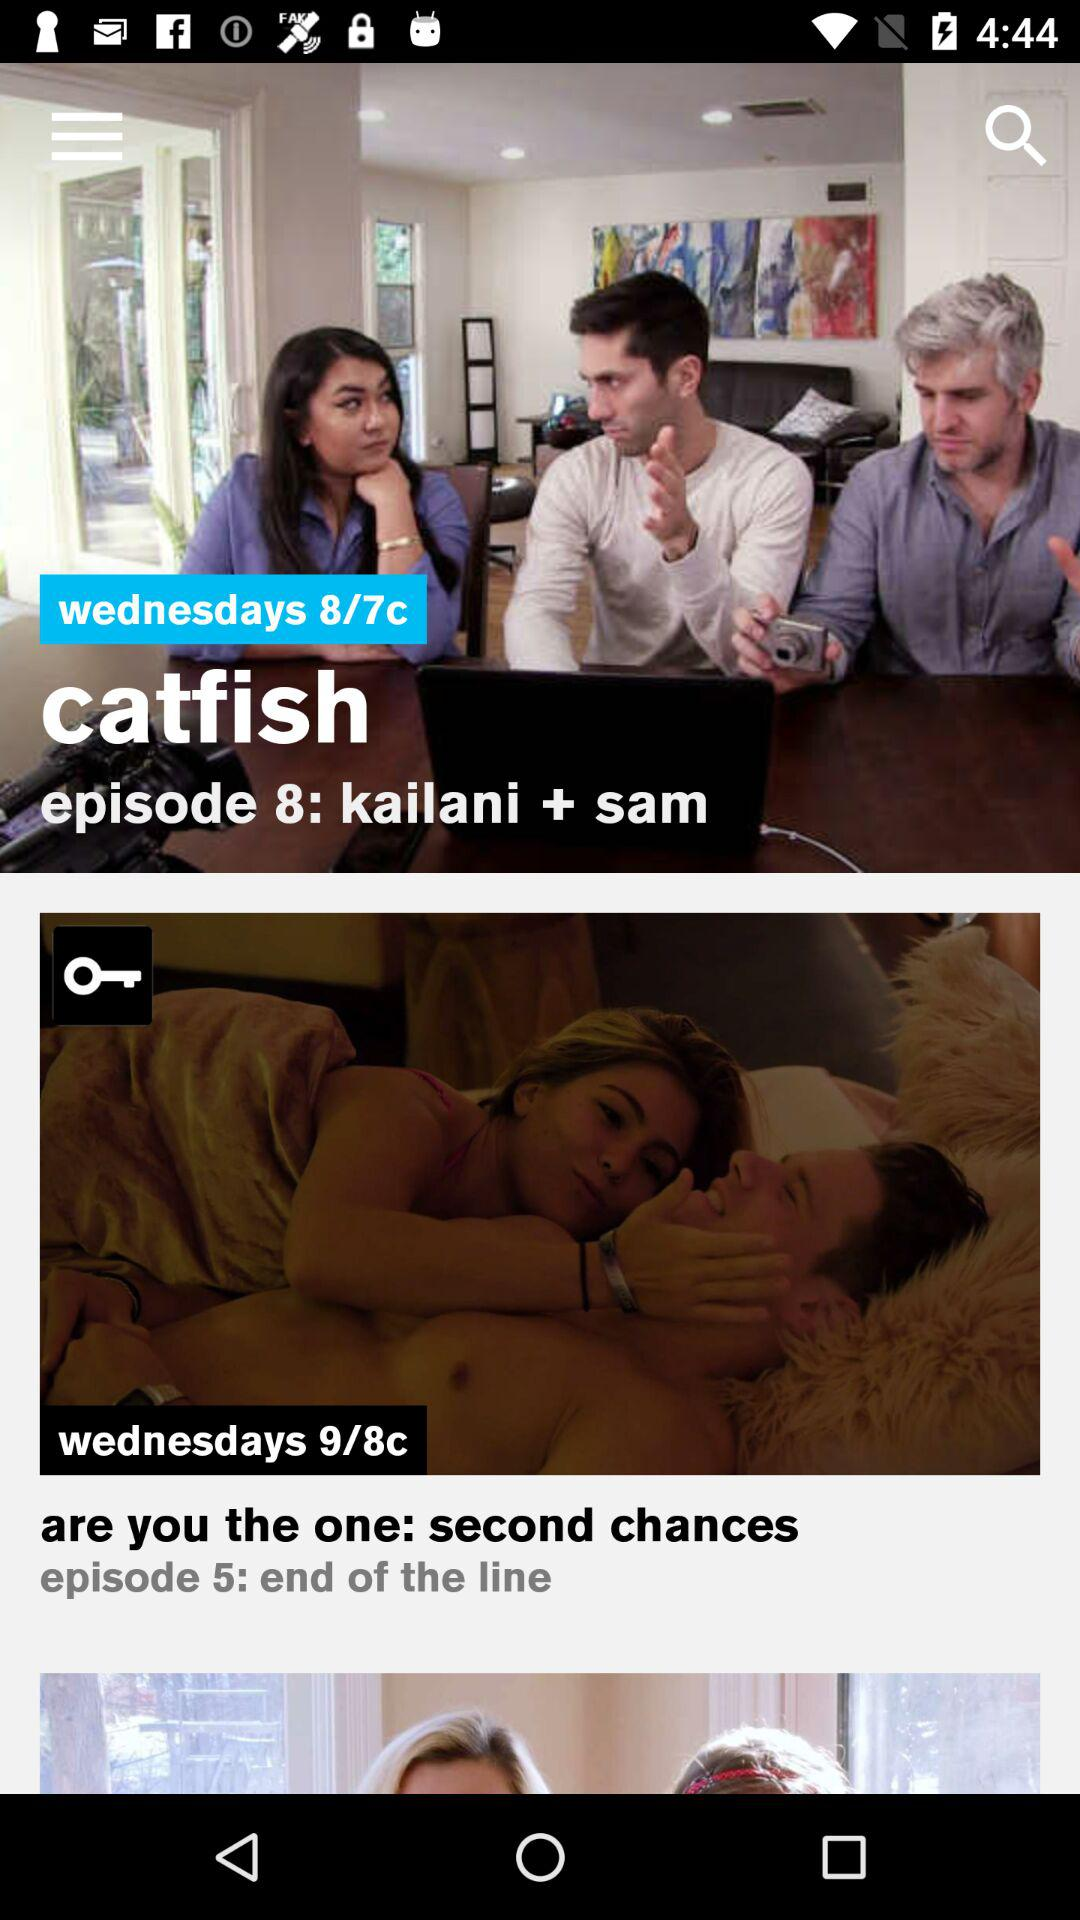How many episodes of Are You the One: Second Chances are there?
Answer the question using a single word or phrase. 5 